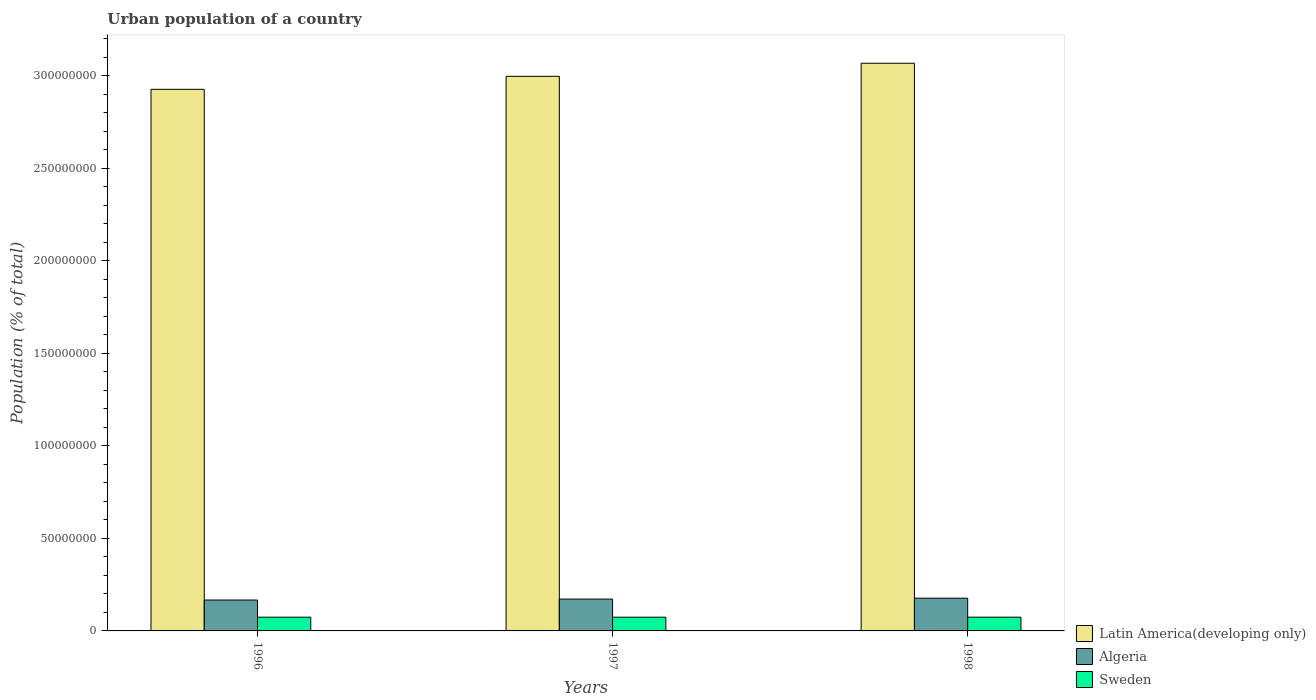How many bars are there on the 1st tick from the right?
Provide a short and direct response. 3. What is the label of the 1st group of bars from the left?
Your answer should be very brief. 1996. What is the urban population in Latin America(developing only) in 1998?
Ensure brevity in your answer.  3.07e+08. Across all years, what is the maximum urban population in Latin America(developing only)?
Your answer should be very brief. 3.07e+08. Across all years, what is the minimum urban population in Sweden?
Provide a short and direct response. 7.42e+06. What is the total urban population in Sweden in the graph?
Make the answer very short. 2.23e+07. What is the difference between the urban population in Latin America(developing only) in 1996 and that in 1998?
Provide a short and direct response. -1.41e+07. What is the difference between the urban population in Latin America(developing only) in 1997 and the urban population in Algeria in 1996?
Your answer should be very brief. 2.83e+08. What is the average urban population in Algeria per year?
Your answer should be very brief. 1.72e+07. In the year 1998, what is the difference between the urban population in Algeria and urban population in Sweden?
Provide a short and direct response. 1.03e+07. What is the ratio of the urban population in Algeria in 1997 to that in 1998?
Your answer should be very brief. 0.97. Is the urban population in Sweden in 1996 less than that in 1998?
Provide a succinct answer. Yes. Is the difference between the urban population in Algeria in 1996 and 1997 greater than the difference between the urban population in Sweden in 1996 and 1997?
Ensure brevity in your answer.  No. What is the difference between the highest and the second highest urban population in Latin America(developing only)?
Offer a terse response. 7.05e+06. What is the difference between the highest and the lowest urban population in Algeria?
Ensure brevity in your answer.  9.92e+05. In how many years, is the urban population in Latin America(developing only) greater than the average urban population in Latin America(developing only) taken over all years?
Offer a terse response. 1. Is the sum of the urban population in Latin America(developing only) in 1996 and 1998 greater than the maximum urban population in Algeria across all years?
Offer a terse response. Yes. What does the 1st bar from the left in 1996 represents?
Offer a terse response. Latin America(developing only). What does the 2nd bar from the right in 1997 represents?
Your answer should be very brief. Algeria. Is it the case that in every year, the sum of the urban population in Sweden and urban population in Algeria is greater than the urban population in Latin America(developing only)?
Provide a succinct answer. No. How many bars are there?
Keep it short and to the point. 9. How many years are there in the graph?
Offer a very short reply. 3. Does the graph contain any zero values?
Your answer should be very brief. No. How are the legend labels stacked?
Give a very brief answer. Vertical. What is the title of the graph?
Offer a very short reply. Urban population of a country. Does "Tonga" appear as one of the legend labels in the graph?
Your answer should be compact. No. What is the label or title of the X-axis?
Ensure brevity in your answer.  Years. What is the label or title of the Y-axis?
Make the answer very short. Population (% of total). What is the Population (% of total) of Latin America(developing only) in 1996?
Ensure brevity in your answer.  2.93e+08. What is the Population (% of total) of Algeria in 1996?
Offer a terse response. 1.67e+07. What is the Population (% of total) in Sweden in 1996?
Offer a very short reply. 7.42e+06. What is the Population (% of total) in Latin America(developing only) in 1997?
Make the answer very short. 3.00e+08. What is the Population (% of total) of Algeria in 1997?
Offer a very short reply. 1.72e+07. What is the Population (% of total) of Sweden in 1997?
Keep it short and to the point. 7.43e+06. What is the Population (% of total) in Latin America(developing only) in 1998?
Offer a very short reply. 3.07e+08. What is the Population (% of total) of Algeria in 1998?
Make the answer very short. 1.77e+07. What is the Population (% of total) of Sweden in 1998?
Your response must be concise. 7.43e+06. Across all years, what is the maximum Population (% of total) in Latin America(developing only)?
Your answer should be very brief. 3.07e+08. Across all years, what is the maximum Population (% of total) in Algeria?
Give a very brief answer. 1.77e+07. Across all years, what is the maximum Population (% of total) of Sweden?
Your answer should be very brief. 7.43e+06. Across all years, what is the minimum Population (% of total) in Latin America(developing only)?
Offer a very short reply. 2.93e+08. Across all years, what is the minimum Population (% of total) in Algeria?
Give a very brief answer. 1.67e+07. Across all years, what is the minimum Population (% of total) in Sweden?
Your answer should be compact. 7.42e+06. What is the total Population (% of total) of Latin America(developing only) in the graph?
Give a very brief answer. 8.99e+08. What is the total Population (% of total) in Algeria in the graph?
Ensure brevity in your answer.  5.16e+07. What is the total Population (% of total) of Sweden in the graph?
Make the answer very short. 2.23e+07. What is the difference between the Population (% of total) in Latin America(developing only) in 1996 and that in 1997?
Keep it short and to the point. -7.03e+06. What is the difference between the Population (% of total) in Algeria in 1996 and that in 1997?
Keep it short and to the point. -5.00e+05. What is the difference between the Population (% of total) of Sweden in 1996 and that in 1997?
Offer a terse response. -6726. What is the difference between the Population (% of total) in Latin America(developing only) in 1996 and that in 1998?
Ensure brevity in your answer.  -1.41e+07. What is the difference between the Population (% of total) of Algeria in 1996 and that in 1998?
Offer a very short reply. -9.92e+05. What is the difference between the Population (% of total) of Sweden in 1996 and that in 1998?
Ensure brevity in your answer.  -1.33e+04. What is the difference between the Population (% of total) in Latin America(developing only) in 1997 and that in 1998?
Your answer should be very brief. -7.05e+06. What is the difference between the Population (% of total) in Algeria in 1997 and that in 1998?
Keep it short and to the point. -4.92e+05. What is the difference between the Population (% of total) in Sweden in 1997 and that in 1998?
Your answer should be very brief. -6602. What is the difference between the Population (% of total) in Latin America(developing only) in 1996 and the Population (% of total) in Algeria in 1997?
Provide a succinct answer. 2.75e+08. What is the difference between the Population (% of total) in Latin America(developing only) in 1996 and the Population (% of total) in Sweden in 1997?
Keep it short and to the point. 2.85e+08. What is the difference between the Population (% of total) in Algeria in 1996 and the Population (% of total) in Sweden in 1997?
Your answer should be very brief. 9.27e+06. What is the difference between the Population (% of total) of Latin America(developing only) in 1996 and the Population (% of total) of Algeria in 1998?
Give a very brief answer. 2.75e+08. What is the difference between the Population (% of total) in Latin America(developing only) in 1996 and the Population (% of total) in Sweden in 1998?
Offer a very short reply. 2.85e+08. What is the difference between the Population (% of total) of Algeria in 1996 and the Population (% of total) of Sweden in 1998?
Make the answer very short. 9.27e+06. What is the difference between the Population (% of total) in Latin America(developing only) in 1997 and the Population (% of total) in Algeria in 1998?
Your answer should be very brief. 2.82e+08. What is the difference between the Population (% of total) of Latin America(developing only) in 1997 and the Population (% of total) of Sweden in 1998?
Your answer should be compact. 2.92e+08. What is the difference between the Population (% of total) of Algeria in 1997 and the Population (% of total) of Sweden in 1998?
Your answer should be very brief. 9.77e+06. What is the average Population (% of total) of Latin America(developing only) per year?
Provide a short and direct response. 3.00e+08. What is the average Population (% of total) in Algeria per year?
Provide a short and direct response. 1.72e+07. What is the average Population (% of total) in Sweden per year?
Make the answer very short. 7.43e+06. In the year 1996, what is the difference between the Population (% of total) of Latin America(developing only) and Population (% of total) of Algeria?
Offer a very short reply. 2.76e+08. In the year 1996, what is the difference between the Population (% of total) in Latin America(developing only) and Population (% of total) in Sweden?
Offer a very short reply. 2.85e+08. In the year 1996, what is the difference between the Population (% of total) of Algeria and Population (% of total) of Sweden?
Ensure brevity in your answer.  9.28e+06. In the year 1997, what is the difference between the Population (% of total) of Latin America(developing only) and Population (% of total) of Algeria?
Make the answer very short. 2.82e+08. In the year 1997, what is the difference between the Population (% of total) in Latin America(developing only) and Population (% of total) in Sweden?
Offer a terse response. 2.92e+08. In the year 1997, what is the difference between the Population (% of total) in Algeria and Population (% of total) in Sweden?
Your response must be concise. 9.77e+06. In the year 1998, what is the difference between the Population (% of total) of Latin America(developing only) and Population (% of total) of Algeria?
Keep it short and to the point. 2.89e+08. In the year 1998, what is the difference between the Population (% of total) of Latin America(developing only) and Population (% of total) of Sweden?
Provide a short and direct response. 2.99e+08. In the year 1998, what is the difference between the Population (% of total) of Algeria and Population (% of total) of Sweden?
Provide a succinct answer. 1.03e+07. What is the ratio of the Population (% of total) of Latin America(developing only) in 1996 to that in 1997?
Your response must be concise. 0.98. What is the ratio of the Population (% of total) in Algeria in 1996 to that in 1997?
Provide a succinct answer. 0.97. What is the ratio of the Population (% of total) of Latin America(developing only) in 1996 to that in 1998?
Offer a terse response. 0.95. What is the ratio of the Population (% of total) in Algeria in 1996 to that in 1998?
Your answer should be compact. 0.94. What is the ratio of the Population (% of total) in Latin America(developing only) in 1997 to that in 1998?
Keep it short and to the point. 0.98. What is the ratio of the Population (% of total) in Algeria in 1997 to that in 1998?
Keep it short and to the point. 0.97. What is the ratio of the Population (% of total) of Sweden in 1997 to that in 1998?
Keep it short and to the point. 1. What is the difference between the highest and the second highest Population (% of total) of Latin America(developing only)?
Offer a terse response. 7.05e+06. What is the difference between the highest and the second highest Population (% of total) of Algeria?
Offer a very short reply. 4.92e+05. What is the difference between the highest and the second highest Population (% of total) in Sweden?
Your answer should be very brief. 6602. What is the difference between the highest and the lowest Population (% of total) in Latin America(developing only)?
Your answer should be compact. 1.41e+07. What is the difference between the highest and the lowest Population (% of total) of Algeria?
Give a very brief answer. 9.92e+05. What is the difference between the highest and the lowest Population (% of total) of Sweden?
Make the answer very short. 1.33e+04. 